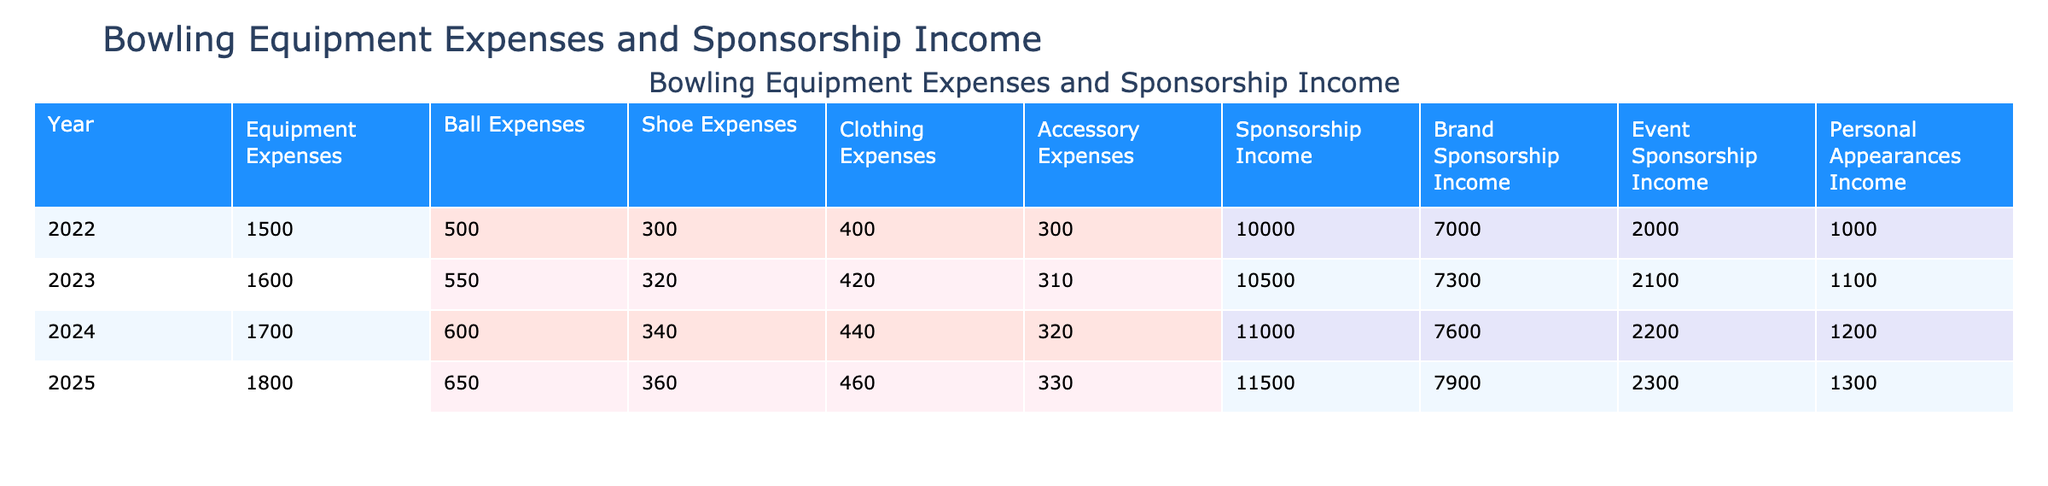What were the Equipment Expenses in 2024? The Equipment Expenses for the year 2024 are listed directly in the table, specifically in the Equipment Expenses column corresponding to that year. The value is 1700.
Answer: 1700 What is the total Sponsorship Income for the years 2022 and 2023 combined? To find the total Sponsorship Income for 2022 and 2023, we add the respective values from the Sponsorship Income column: 10000 (2022) + 10500 (2023) = 20500.
Answer: 20500 Did the Ball Expenses increase from 2022 to 2024? We compare the Ball Expenses for 2022 and 2024. The expense was 500 in 2022 and increased to 600 in 2024, indicating an increase.
Answer: Yes What is the average Clothing Expenses from 2022 to 2025? To calculate the average, we first sum the Clothing Expenses for the years: 400 + 420 + 440 + 460 = 1720. Then we divide this sum by the number of years (4): 1720 / 4 = 430.
Answer: 430 What was the highest Personal Appearances Income recorded in the table? By examining the Personal Appearances Income column, we find the values for each year: 1000 (2022), 1100 (2023), 1200 (2024), and 1300 (2025). The highest value is 1300 in 2025.
Answer: 1300 What was the difference in Accessory Expenses between 2022 and 2025? The Accessory Expenses for 2022 were 300, and for 2025, they were 330. The difference is calculated by subtracting the two amounts: 330 - 300 = 30.
Answer: 30 Is the Brand Sponsorship Income for 2023 lower than for 2024? The Brand Sponsorship Income values are 7300 for 2023 and 7600 for 2024. Since 7300 is less than 7600, the statement is true.
Answer: Yes What is the total of all Equipment Expenses from 2022 to 2025? To find the total, we sum all the Equipment Expenses over the four years: 1500 (2022) + 1600 (2023) + 1700 (2024) + 1800 (2025) = 6600.
Answer: 6600 